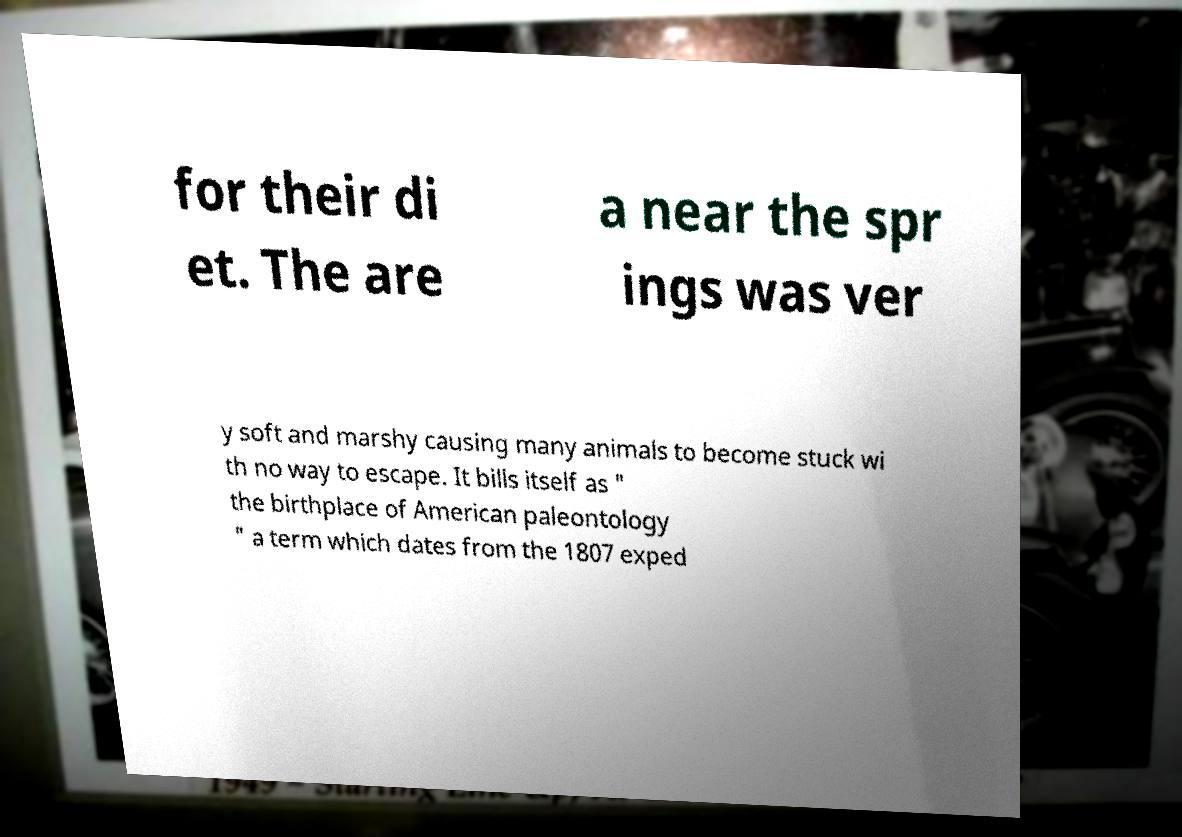There's text embedded in this image that I need extracted. Can you transcribe it verbatim? for their di et. The are a near the spr ings was ver y soft and marshy causing many animals to become stuck wi th no way to escape. It bills itself as " the birthplace of American paleontology " a term which dates from the 1807 exped 